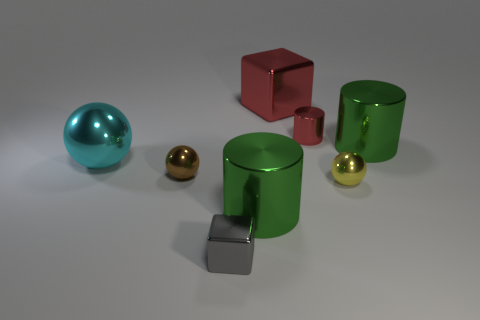Assuming these objects are part of a game, what might be the objective? If these objects were part of a game, the objective could be one of spatial recognition and manipulation. For example, players might need to arrange the objects according to specific rules related to their colors, shapes, or materials. The game could involve challenges such as balancing the spheres on the cylindrical objects, constructing a structure using the cube and cylinders, or even creating patterns based on reflective properties under certain lighting conditions. 